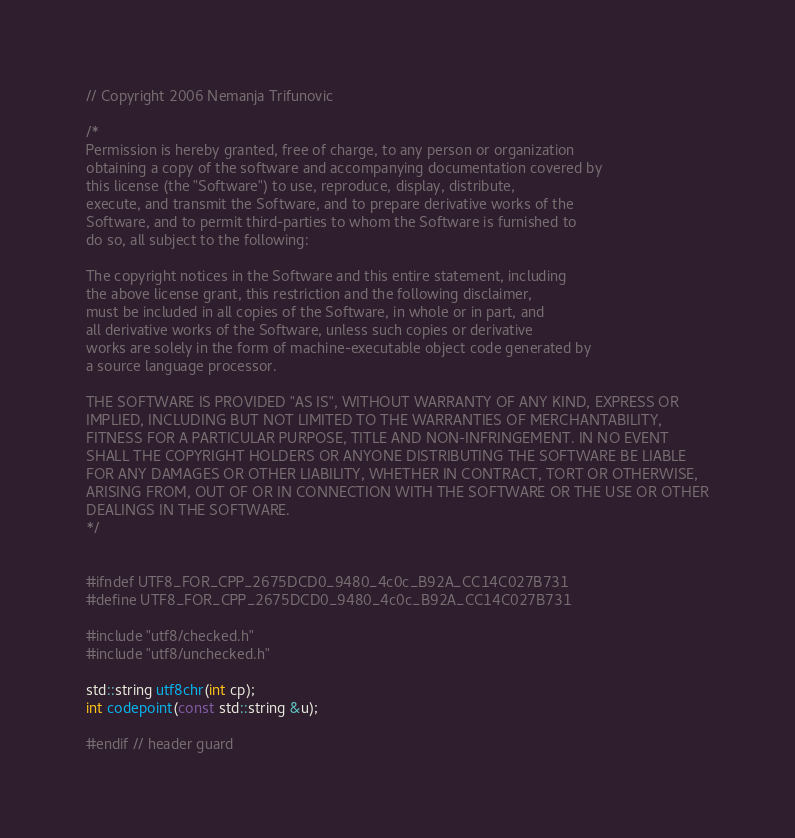Convert code to text. <code><loc_0><loc_0><loc_500><loc_500><_C_>// Copyright 2006 Nemanja Trifunovic

/*
Permission is hereby granted, free of charge, to any person or organization
obtaining a copy of the software and accompanying documentation covered by
this license (the "Software") to use, reproduce, display, distribute,
execute, and transmit the Software, and to prepare derivative works of the
Software, and to permit third-parties to whom the Software is furnished to
do so, all subject to the following:

The copyright notices in the Software and this entire statement, including
the above license grant, this restriction and the following disclaimer,
must be included in all copies of the Software, in whole or in part, and
all derivative works of the Software, unless such copies or derivative
works are solely in the form of machine-executable object code generated by
a source language processor.

THE SOFTWARE IS PROVIDED "AS IS", WITHOUT WARRANTY OF ANY KIND, EXPRESS OR
IMPLIED, INCLUDING BUT NOT LIMITED TO THE WARRANTIES OF MERCHANTABILITY,
FITNESS FOR A PARTICULAR PURPOSE, TITLE AND NON-INFRINGEMENT. IN NO EVENT
SHALL THE COPYRIGHT HOLDERS OR ANYONE DISTRIBUTING THE SOFTWARE BE LIABLE
FOR ANY DAMAGES OR OTHER LIABILITY, WHETHER IN CONTRACT, TORT OR OTHERWISE,
ARISING FROM, OUT OF OR IN CONNECTION WITH THE SOFTWARE OR THE USE OR OTHER
DEALINGS IN THE SOFTWARE.
*/


#ifndef UTF8_FOR_CPP_2675DCD0_9480_4c0c_B92A_CC14C027B731
#define UTF8_FOR_CPP_2675DCD0_9480_4c0c_B92A_CC14C027B731

#include "utf8/checked.h"
#include "utf8/unchecked.h"

std::string utf8chr(int cp);
int codepoint(const std::string &u);
  
#endif // header guard
</code> 